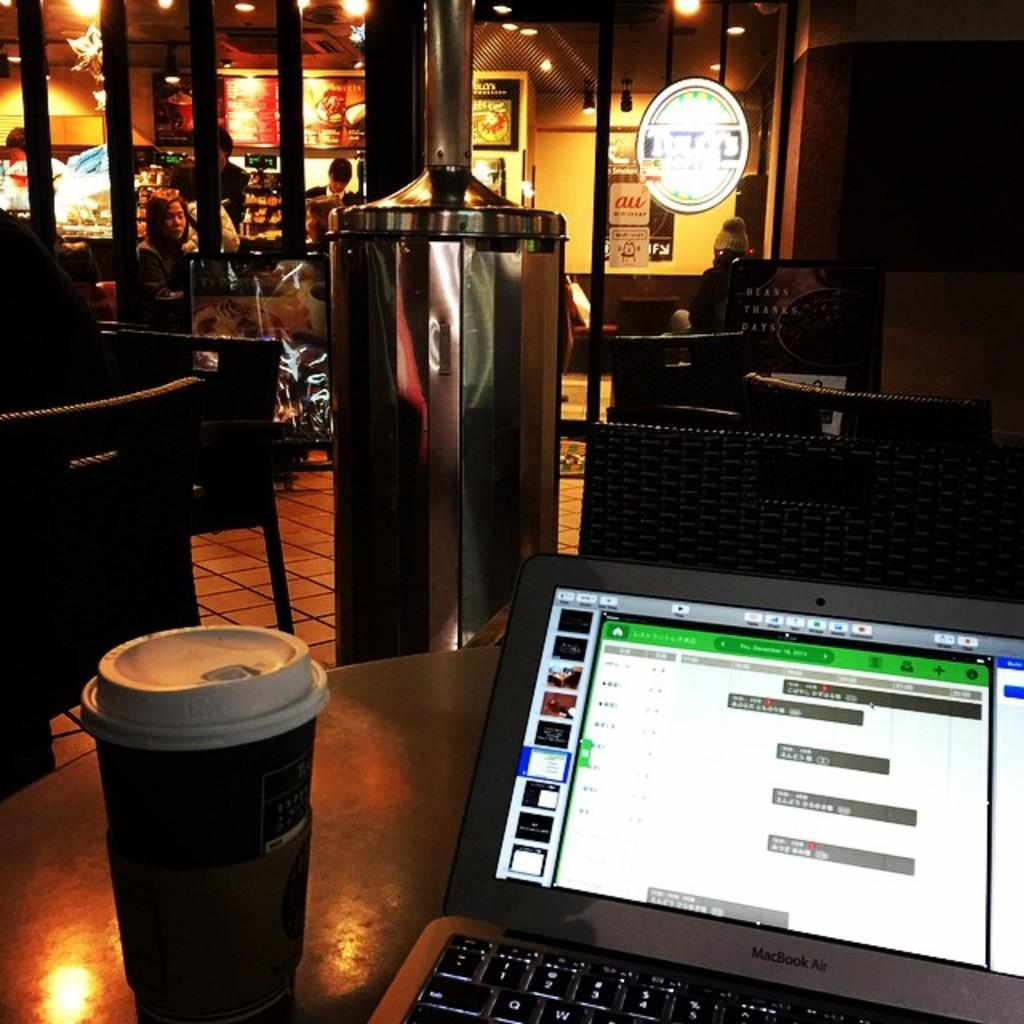<image>
Give a short and clear explanation of the subsequent image. A small white sign on the glass at the coffee shop says "au". 